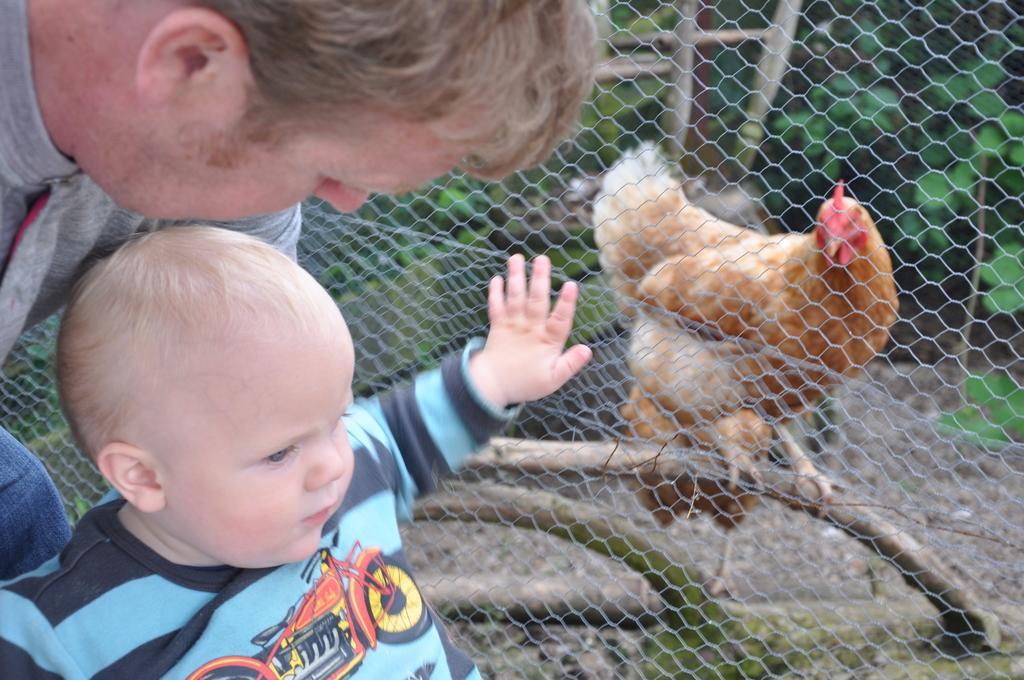Please provide a concise description of this image. In the image there is a man and a baby standing on the left side and behind them there is a net with a hen standing on a plant behind it, followed by plants on the land. 